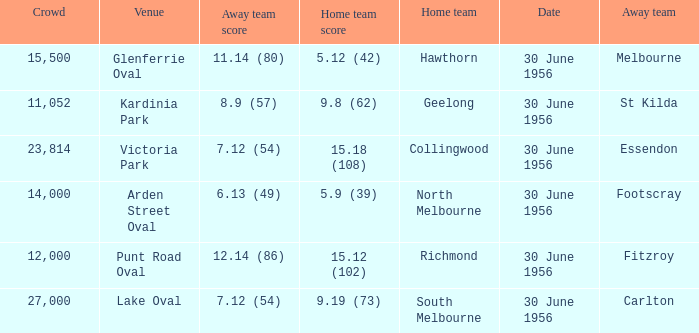What is the home team score when the away team is Melbourne? 5.12 (42). Could you help me parse every detail presented in this table? {'header': ['Crowd', 'Venue', 'Away team score', 'Home team score', 'Home team', 'Date', 'Away team'], 'rows': [['15,500', 'Glenferrie Oval', '11.14 (80)', '5.12 (42)', 'Hawthorn', '30 June 1956', 'Melbourne'], ['11,052', 'Kardinia Park', '8.9 (57)', '9.8 (62)', 'Geelong', '30 June 1956', 'St Kilda'], ['23,814', 'Victoria Park', '7.12 (54)', '15.18 (108)', 'Collingwood', '30 June 1956', 'Essendon'], ['14,000', 'Arden Street Oval', '6.13 (49)', '5.9 (39)', 'North Melbourne', '30 June 1956', 'Footscray'], ['12,000', 'Punt Road Oval', '12.14 (86)', '15.12 (102)', 'Richmond', '30 June 1956', 'Fitzroy'], ['27,000', 'Lake Oval', '7.12 (54)', '9.19 (73)', 'South Melbourne', '30 June 1956', 'Carlton']]} 